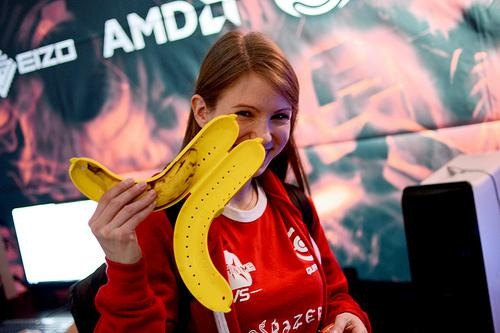Question: what color is the girls hair?
Choices:
A. The girls hair is green.
B. The girls hair is red.
C. The girls hair is blue.
D. The girls hair is black.
Answer with the letter. Answer: B Question: who took the picture?
Choices:
A. A sister's friend.
B. My aunt.
C. A friend of the girl.
D. Her brother.
Answer with the letter. Answer: C 